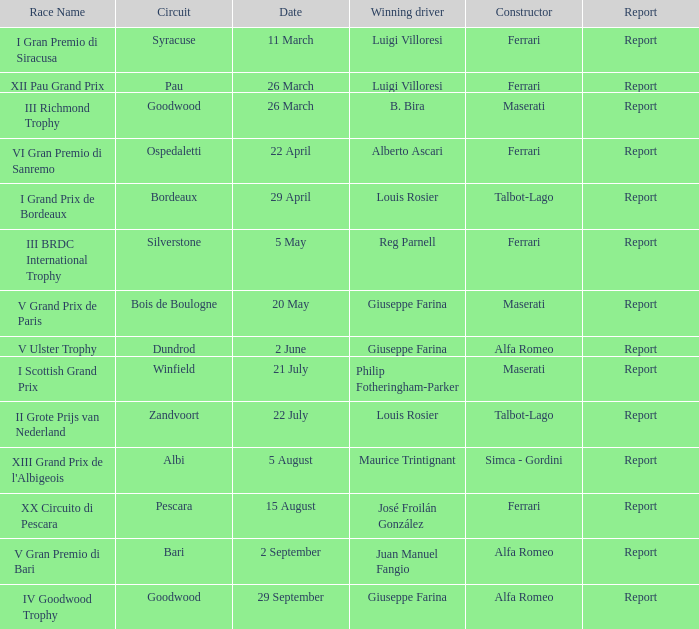Name the date for pescara 15 August. 